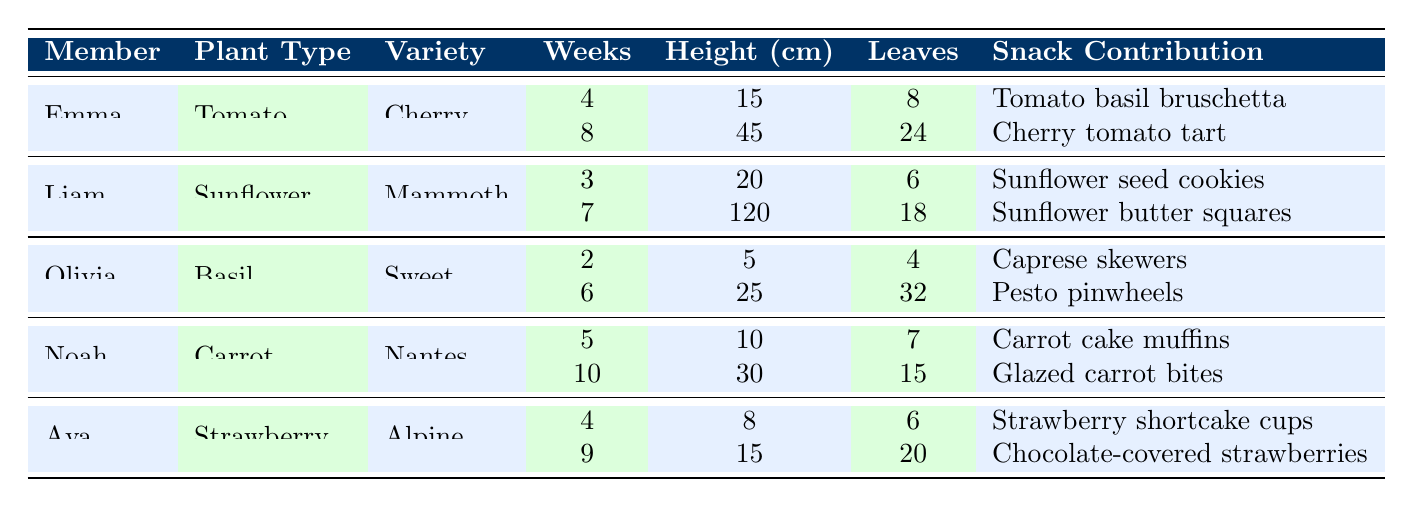What is the height of Liam's sunflower after 7 weeks? According to the table, Liam's sunflower is 120 cm tall after 7 weeks of growth.
Answer: 120 cm How many leaves does Emma's tomato plant have after 8 weeks? After 8 weeks, Emma's tomato plant has 24 leaves based on the data in the table.
Answer: 24 leaves Which member contributed "Pesto pinwheels" as a snack? The table indicates that Olivia contributed "Pesto pinwheels".
Answer: Olivia What is the difference in height of Noah's carrot between 5 and 10 weeks? At 5 weeks, Noah's carrot is 10 cm tall and at 10 weeks, it is 30 cm tall. The difference is 30 cm - 10 cm = 20 cm.
Answer: 20 cm What plant type did Ava cultivate? The table shows that Ava cultivated strawberries.
Answer: Strawberry What is the average height of Emma's tomato plants? Emma's tomato plants are 15 cm (4 weeks) and 45 cm (8 weeks) tall. The average height is (15 cm + 45 cm) / 2 = 30 cm.
Answer: 30 cm Did Olivia's basil plants grow taller over the 6 weeks? Yes, Olivia's basil grew from 5 cm after 2 weeks to 25 cm after 6 weeks, indicating growth.
Answer: Yes Who has the highest number of leaves among all the members' plants? Olivia has the highest number of leaves with 32 leaves from her basil plant at 6 weeks.
Answer: Olivia What is the total number of leaves for Noah's carrot plants? Noah's carrot plants have 7 leaves at 5 weeks and 15 leaves at 10 weeks. The total is 7 + 15 = 22 leaves.
Answer: 22 leaves Which plant variety has the largest height at its maximum recorded age? Liam's sunflower variety Mammoth reached a height of 120 cm at 7 weeks, the largest height recorded.
Answer: Sunflower Mammoth 